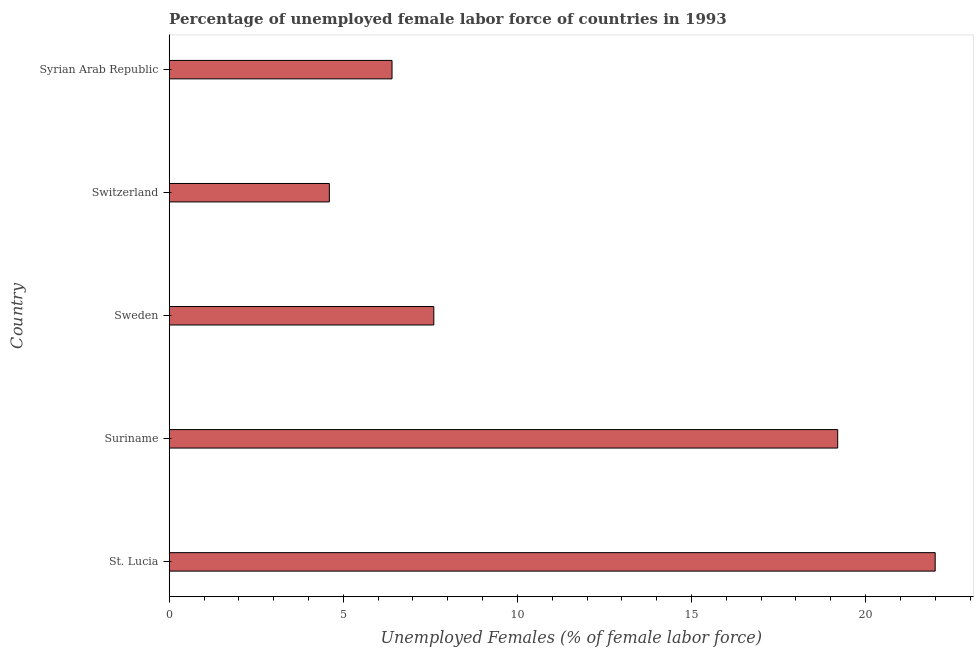What is the title of the graph?
Keep it short and to the point. Percentage of unemployed female labor force of countries in 1993. What is the label or title of the X-axis?
Make the answer very short. Unemployed Females (% of female labor force). What is the label or title of the Y-axis?
Offer a terse response. Country. What is the total unemployed female labour force in Switzerland?
Provide a succinct answer. 4.6. Across all countries, what is the minimum total unemployed female labour force?
Ensure brevity in your answer.  4.6. In which country was the total unemployed female labour force maximum?
Make the answer very short. St. Lucia. In which country was the total unemployed female labour force minimum?
Provide a short and direct response. Switzerland. What is the sum of the total unemployed female labour force?
Ensure brevity in your answer.  59.8. What is the difference between the total unemployed female labour force in St. Lucia and Switzerland?
Offer a very short reply. 17.4. What is the average total unemployed female labour force per country?
Keep it short and to the point. 11.96. What is the median total unemployed female labour force?
Provide a succinct answer. 7.6. In how many countries, is the total unemployed female labour force greater than 7 %?
Make the answer very short. 3. What is the ratio of the total unemployed female labour force in St. Lucia to that in Sweden?
Your answer should be compact. 2.9. Is the total unemployed female labour force in St. Lucia less than that in Suriname?
Make the answer very short. No. Is the difference between the total unemployed female labour force in Sweden and Syrian Arab Republic greater than the difference between any two countries?
Your answer should be compact. No. What is the difference between the highest and the lowest total unemployed female labour force?
Ensure brevity in your answer.  17.4. How many bars are there?
Your response must be concise. 5. Are all the bars in the graph horizontal?
Your answer should be compact. Yes. What is the Unemployed Females (% of female labor force) in Suriname?
Your answer should be very brief. 19.2. What is the Unemployed Females (% of female labor force) of Sweden?
Ensure brevity in your answer.  7.6. What is the Unemployed Females (% of female labor force) of Switzerland?
Your answer should be compact. 4.6. What is the Unemployed Females (% of female labor force) of Syrian Arab Republic?
Provide a succinct answer. 6.4. What is the difference between the Unemployed Females (% of female labor force) in St. Lucia and Sweden?
Provide a short and direct response. 14.4. What is the difference between the Unemployed Females (% of female labor force) in St. Lucia and Switzerland?
Provide a short and direct response. 17.4. What is the difference between the Unemployed Females (% of female labor force) in Suriname and Switzerland?
Keep it short and to the point. 14.6. What is the difference between the Unemployed Females (% of female labor force) in Suriname and Syrian Arab Republic?
Give a very brief answer. 12.8. What is the difference between the Unemployed Females (% of female labor force) in Sweden and Switzerland?
Make the answer very short. 3. What is the difference between the Unemployed Females (% of female labor force) in Switzerland and Syrian Arab Republic?
Your answer should be compact. -1.8. What is the ratio of the Unemployed Females (% of female labor force) in St. Lucia to that in Suriname?
Keep it short and to the point. 1.15. What is the ratio of the Unemployed Females (% of female labor force) in St. Lucia to that in Sweden?
Your answer should be very brief. 2.9. What is the ratio of the Unemployed Females (% of female labor force) in St. Lucia to that in Switzerland?
Offer a very short reply. 4.78. What is the ratio of the Unemployed Females (% of female labor force) in St. Lucia to that in Syrian Arab Republic?
Give a very brief answer. 3.44. What is the ratio of the Unemployed Females (% of female labor force) in Suriname to that in Sweden?
Provide a short and direct response. 2.53. What is the ratio of the Unemployed Females (% of female labor force) in Suriname to that in Switzerland?
Offer a very short reply. 4.17. What is the ratio of the Unemployed Females (% of female labor force) in Sweden to that in Switzerland?
Make the answer very short. 1.65. What is the ratio of the Unemployed Females (% of female labor force) in Sweden to that in Syrian Arab Republic?
Your answer should be very brief. 1.19. What is the ratio of the Unemployed Females (% of female labor force) in Switzerland to that in Syrian Arab Republic?
Offer a terse response. 0.72. 